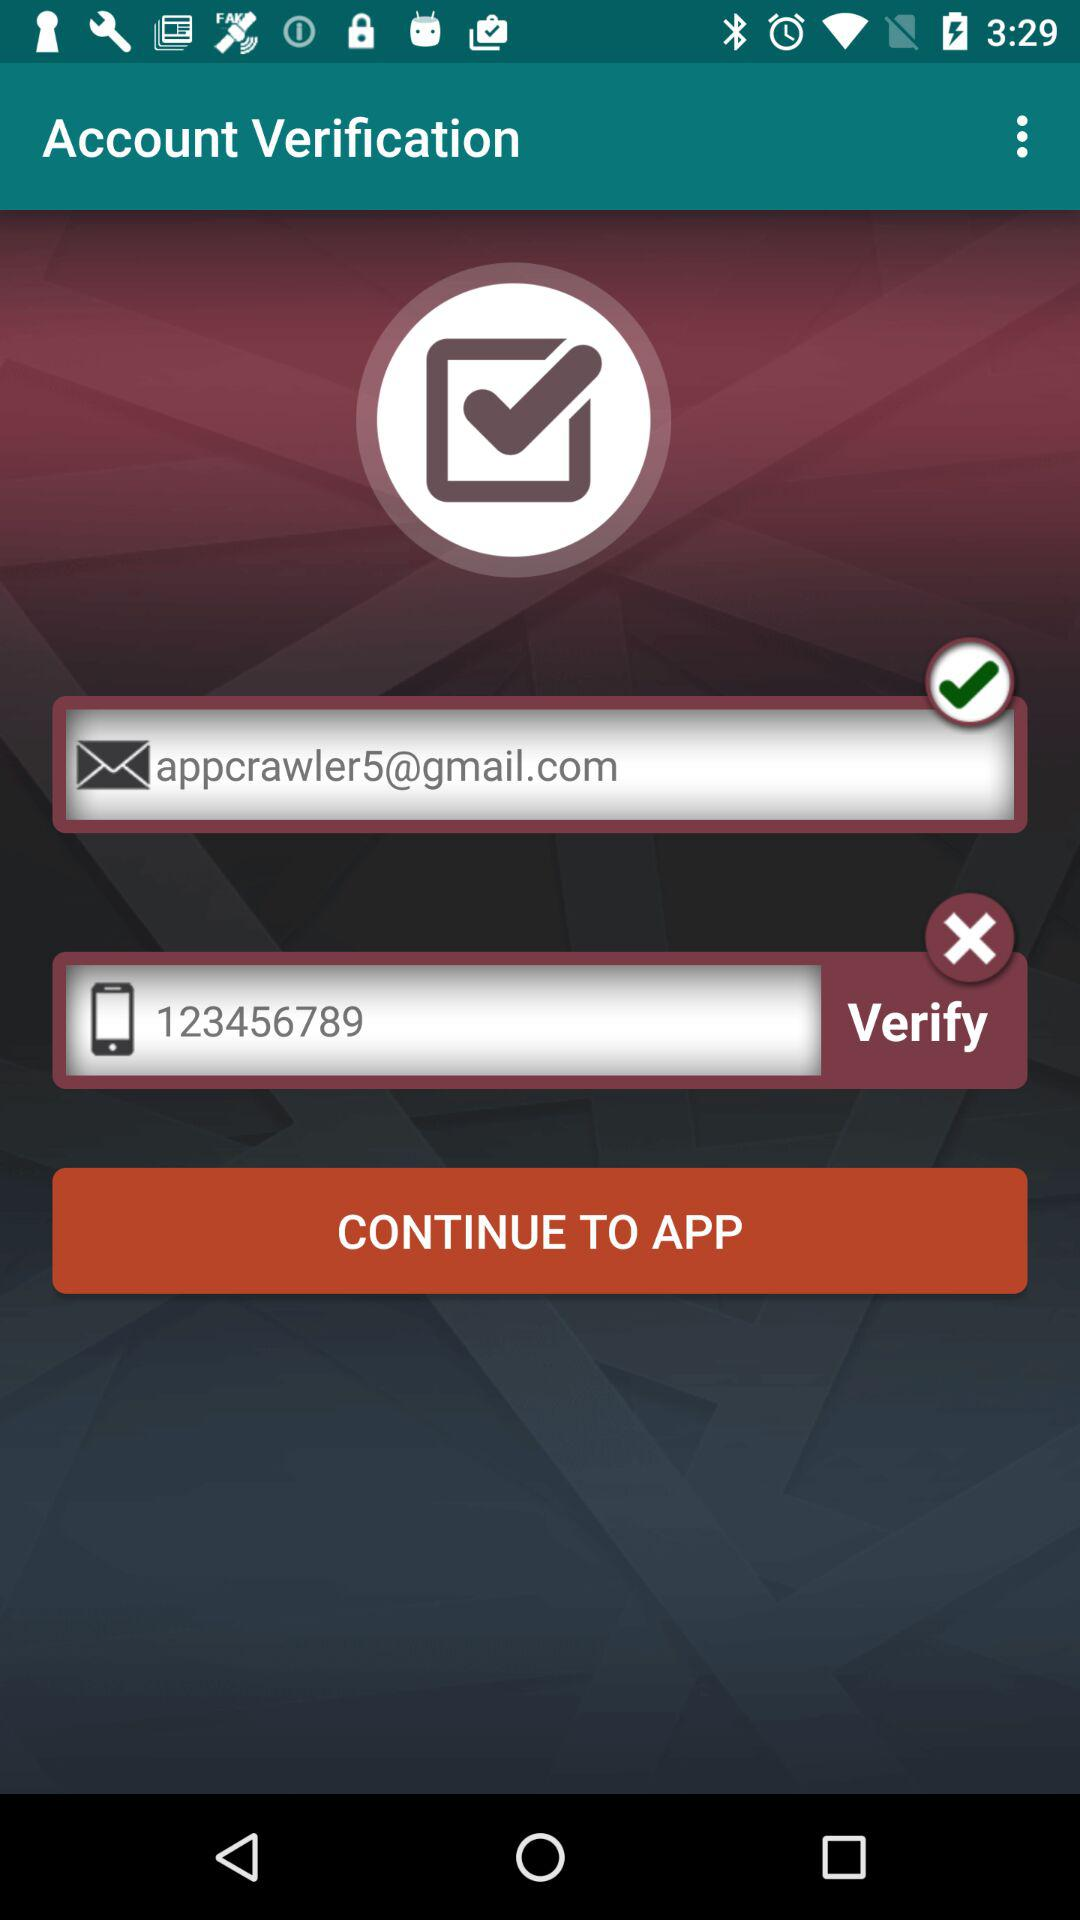What's the selected option for Account Verification?
When the provided information is insufficient, respond with <no answer>. <no answer> 